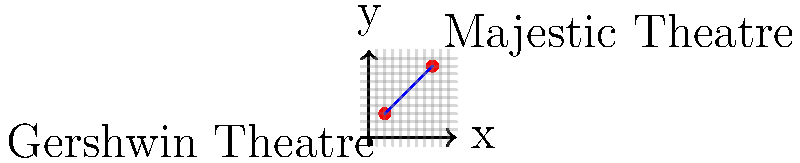As an aspiring Broadway actor, you're interested in the locations of famous theaters. The Gershwin Theatre is located at coordinates (2, 3), and the Majestic Theatre is at (8, 9). What is the slope of the line connecting these two iconic Broadway theaters? To find the slope of the line connecting two points, we use the slope formula:

$$ m = \frac{y_2 - y_1}{x_2 - x_1} $$

Where $(x_1, y_1)$ is the first point and $(x_2, y_2)$ is the second point.

Let's identify our points:
- Gershwin Theatre: $(x_1, y_1) = (2, 3)$
- Majestic Theatre: $(x_2, y_2) = (8, 9)$

Now, let's plug these values into the slope formula:

$$ m = \frac{9 - 3}{8 - 2} = \frac{6}{6} $$

Simplifying this fraction, we get:

$$ m = 1 $$

Therefore, the slope of the line connecting the Gershwin Theatre and the Majestic Theatre is 1.
Answer: 1 